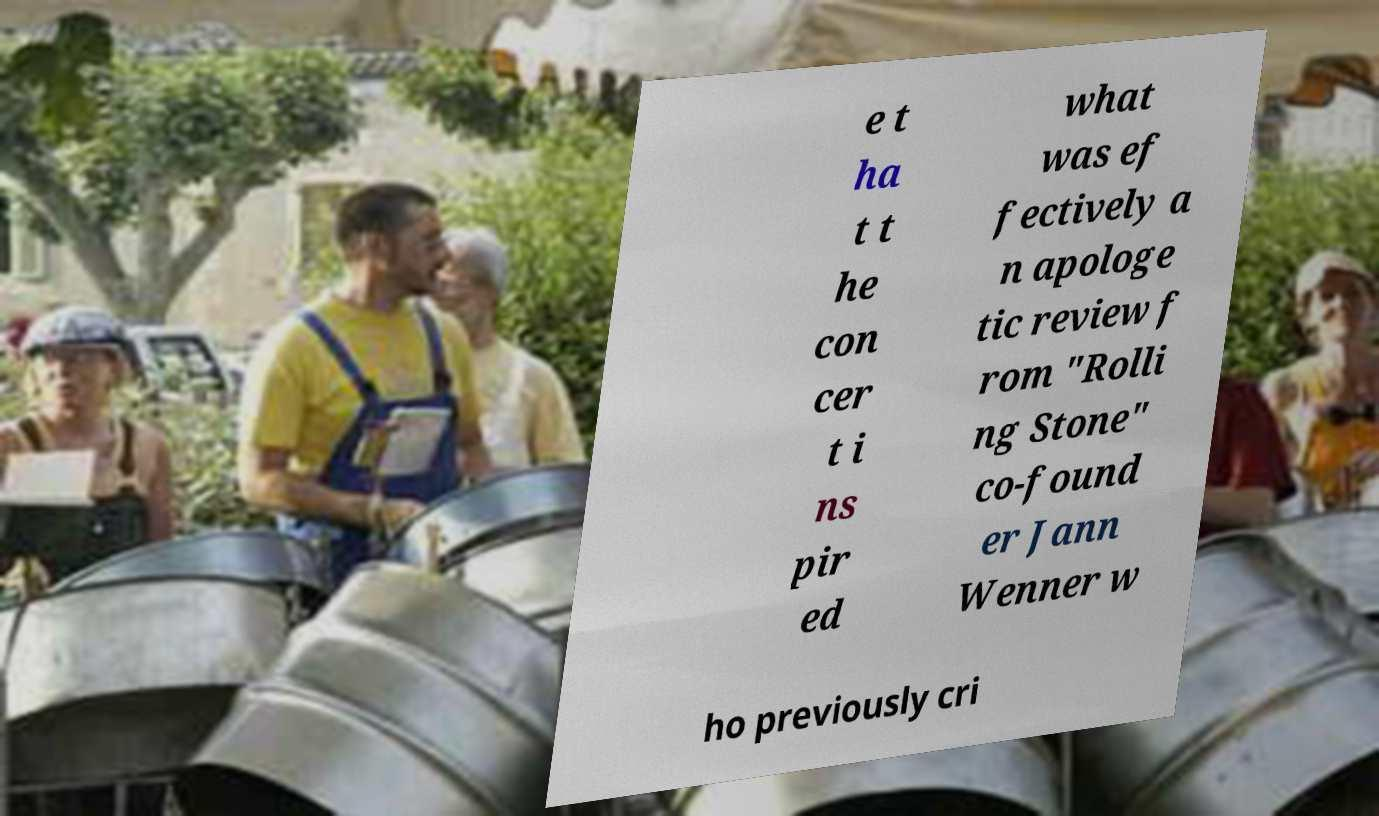Please read and relay the text visible in this image. What does it say? e t ha t t he con cer t i ns pir ed what was ef fectively a n apologe tic review f rom "Rolli ng Stone" co-found er Jann Wenner w ho previously cri 